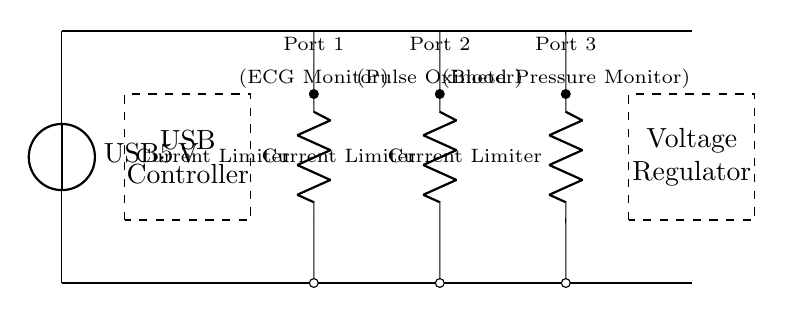What is the voltage of the main supply? The voltage of the main supply is indicated to be 5V, as shown next to the USB power source in the circuit diagram.
Answer: 5V How many charging ports are present? The circuit diagram displays three distinct charging ports labeled for different medical devices, indicating the number of ports present in the design.
Answer: 3 What type of devices can be charged at Port 1? Port 1 is labeled for the ECG monitor, confirming that it is designated for charging this specific type of device.
Answer: ECG Monitor What component regulates the voltage in the circuit? The diagram illustrates a voltage regulator, which is identified in a dashed rectangle, responsible for maintaining a constant voltage output.
Answer: Voltage Regulator Which component serves as a current limiter for Port 2? The current limiter is specified in the diagram next to Port 2, which is drawn as a resistor in series with the charging port, indicating that it limits the current flow to the device connected here.
Answer: Current Limiter What is the purpose of the USB controller? The USB controller, indicated as a dashed rectangle in the diagram, manages the power distribution to the different charging ports, ensuring that each port operates appropriately within specifications.
Answer: Power Management Is the voltage regulator before or after the charging ports in the circuit? The voltage regulator is positioned at the end of the circuit, which means it is after the charging ports, helping to ensure safety and regulation of voltage before supply to the output devices.
Answer: After 